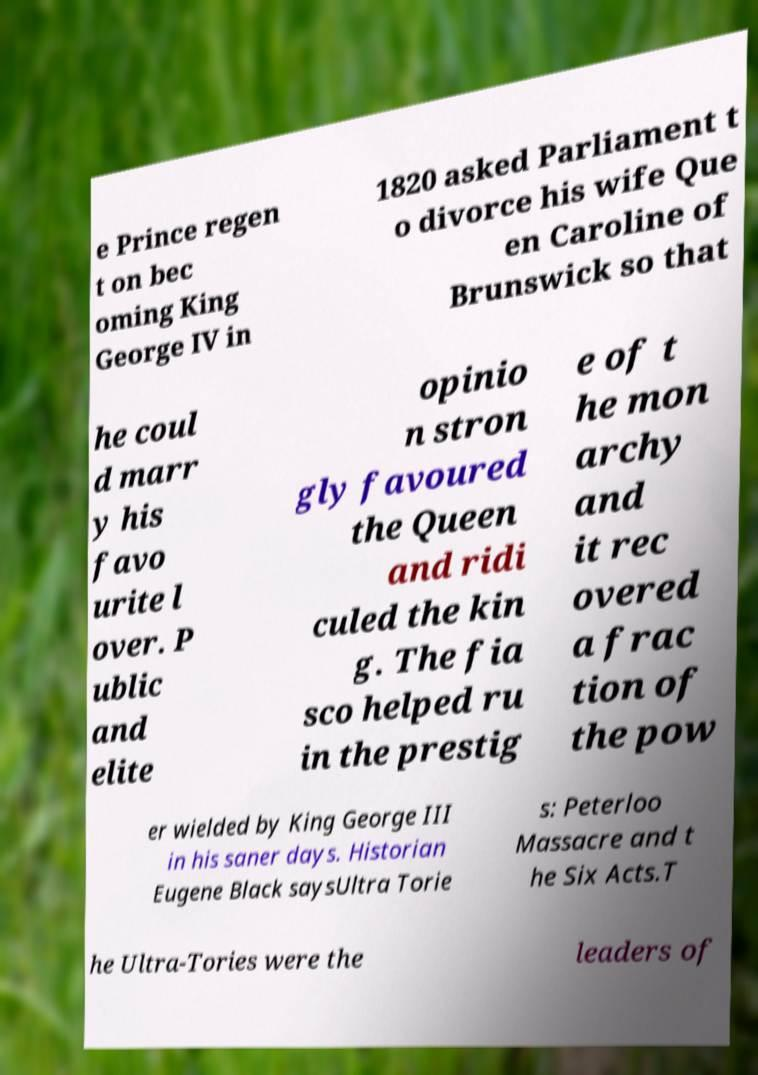I need the written content from this picture converted into text. Can you do that? e Prince regen t on bec oming King George IV in 1820 asked Parliament t o divorce his wife Que en Caroline of Brunswick so that he coul d marr y his favo urite l over. P ublic and elite opinio n stron gly favoured the Queen and ridi culed the kin g. The fia sco helped ru in the prestig e of t he mon archy and it rec overed a frac tion of the pow er wielded by King George III in his saner days. Historian Eugene Black saysUltra Torie s: Peterloo Massacre and t he Six Acts.T he Ultra-Tories were the leaders of 